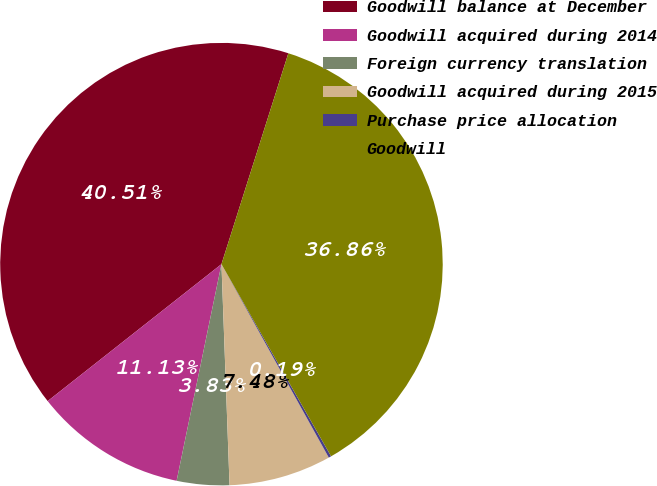<chart> <loc_0><loc_0><loc_500><loc_500><pie_chart><fcel>Goodwill balance at December<fcel>Goodwill acquired during 2014<fcel>Foreign currency translation<fcel>Goodwill acquired during 2015<fcel>Purchase price allocation<fcel>Goodwill<nl><fcel>40.51%<fcel>11.13%<fcel>3.83%<fcel>7.48%<fcel>0.19%<fcel>36.86%<nl></chart> 